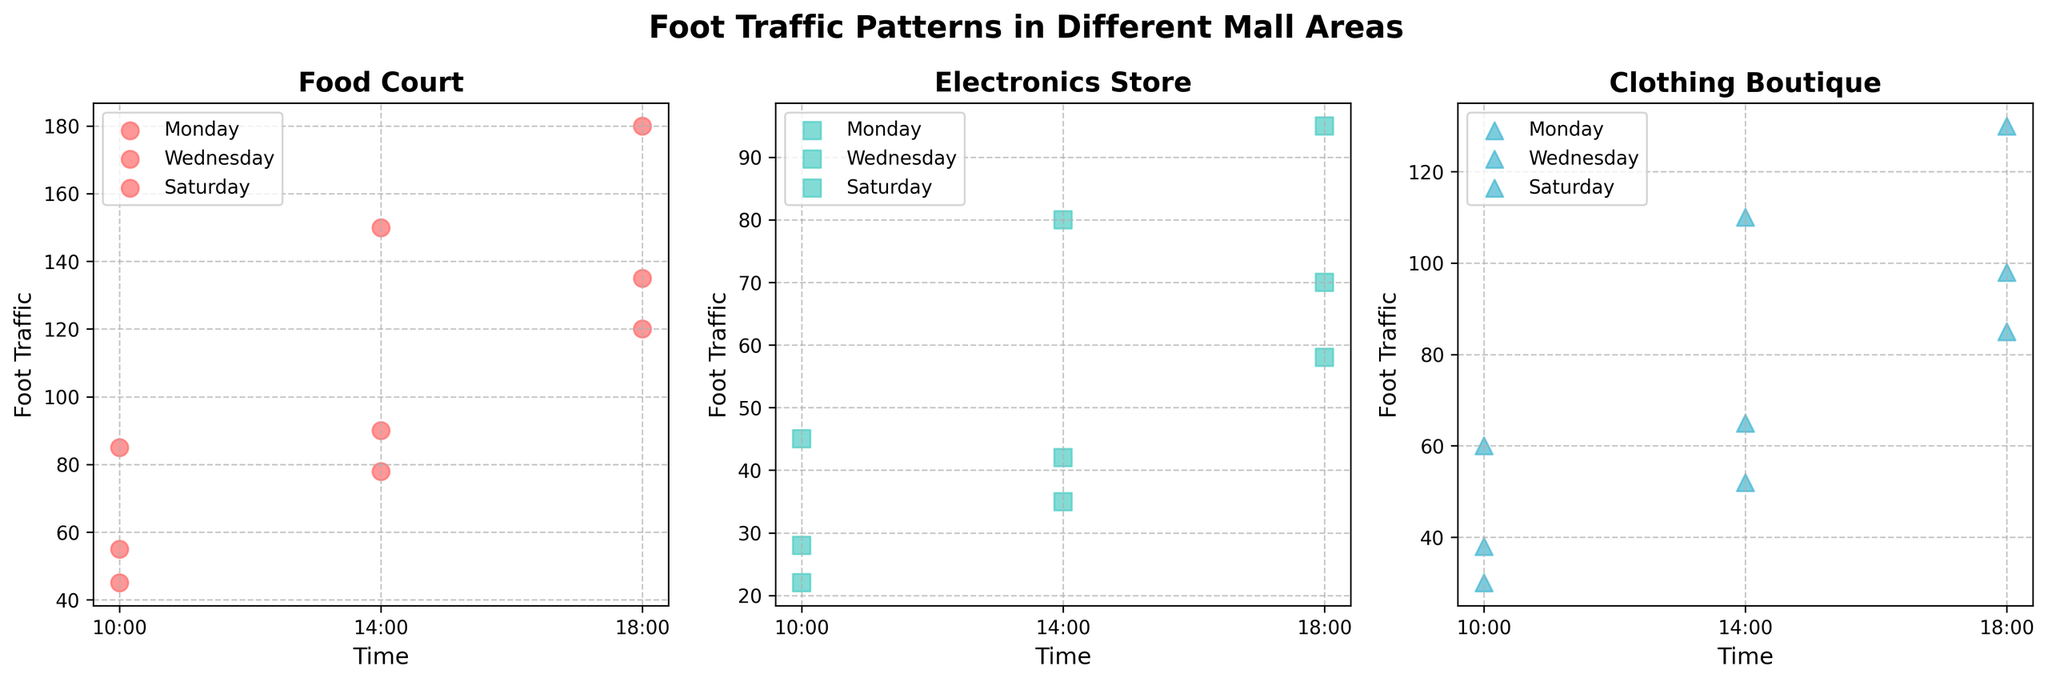What is the title of the figure? The title is displayed at the top of the figure in a bold, large font. It describes the overall subject and purpose of the figure.
Answer: Foot Traffic Patterns in Different Mall Areas How many different areas are represented in the figure? By examining the titles of the three subplots, we can see that each subplot represents a different area.
Answer: 3 Which day has the highest foot traffic in the Food Court at 10:00? We need to look at the data points for the Food Court at 10:00 on each day and compare the values. The points for Monday, Wednesday, and Saturday are 45, 55, and 85, respectively.
Answer: Saturday In which mall area does Saturday at 14:00 have the highest foot traffic? Compare the foot traffic values at 14:00 on Saturday across all three areas by looking at the scatter points. The values are 150 (Food Court), 80 (Electronics Store), and 110 (Clothing Boutique).
Answer: Food Court What is the general trend of foot traffic in the Electronics Store from 10:00 to 18:00 across all days? Observing the scatter points in the Electronics Store subplot, we notice that foot traffic generally increases from 10:00 to 18:00 on all days.
Answer: Increasing Comparing Monday and Wednesday, which day has higher foot traffic in the Clothing Boutique at 14:00? We need to look at the scatter points for the Clothing Boutique at 14:00 on both Monday and Wednesday. The values are 52 (Monday) and 65 (Wednesday).
Answer: Wednesday Which area experiences the greatest increase in foot traffic from 10:00 to 18:00 on Wednesday? Calculate the difference in foot traffic between 10:00 and 18:00 for each area on Wednesday. The values are 80 (Food Court: 55 to 135), 42 (Electronics Store: 28 to 70), and 60 (Clothing Boutique: 38 to 98).
Answer: Food Court Does the Clothing Boutique have a higher foot traffic at 18:00 on Monday or the Electronics Store at 18:00 on Saturday? Compare the foot traffic values at 18:00 on Monday for Clothing Boutique (85) and at 18:00 on Saturday for Electronics Store (95).
Answer: Electronics Store on Saturday Overall, which day sees the highest foot traffic in all areas? Compare the total foot traffic for each area on Monday, Wednesday, and Saturday by summing up the values. Analyzing the scatter points this way, Saturday has the highest values in all areas.
Answer: Saturday 